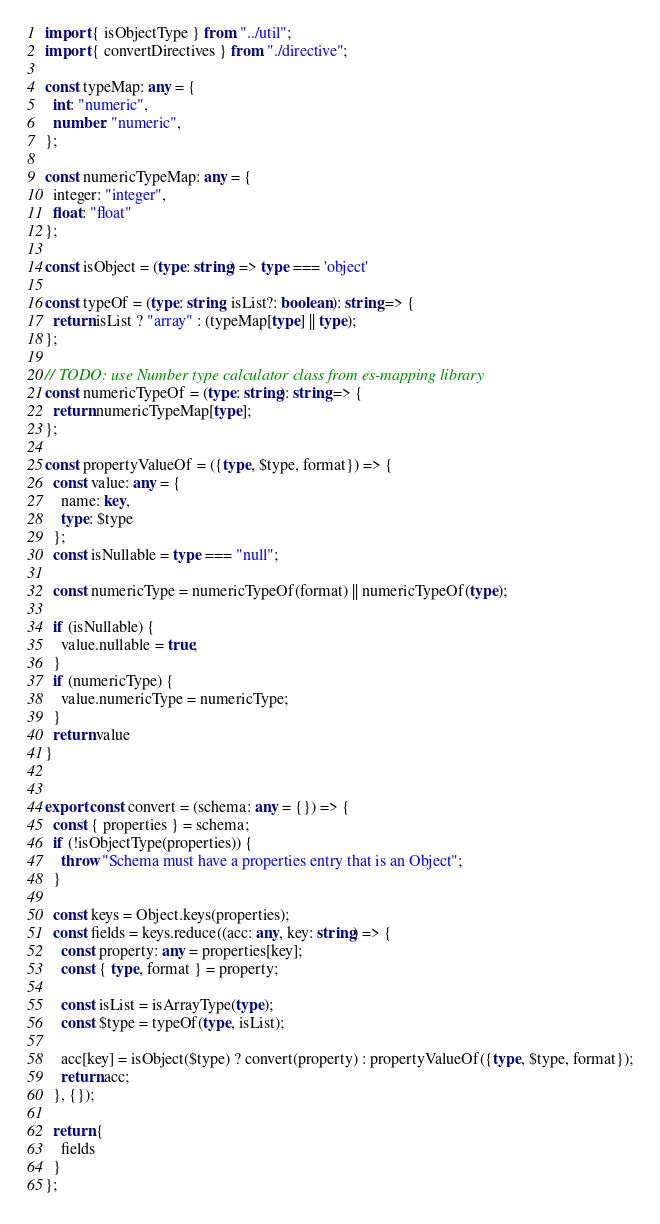<code> <loc_0><loc_0><loc_500><loc_500><_TypeScript_>import { isObjectType } from "../util";
import { convertDirectives } from "./directive";

const typeMap: any = {
  int: "numeric",
  number: "numeric",
};

const numericTypeMap: any = {
  integer: "integer",
  float: "float"
};

const isObject = (type: string) => type === 'object'

const typeOf = (type: string, isList?: boolean): string => {
  return isList ? "array" : (typeMap[type] || type);
};

// TODO: use Number type calculator class from es-mapping library
const numericTypeOf = (type: string): string => {
  return numericTypeMap[type];
};

const propertyValueOf = ({type, $type, format}) => {
  const value: any = {
    name: key,
    type: $type
  };
  const isNullable = type === "null";  

  const numericType = numericTypeOf(format) || numericTypeOf(type);

  if (isNullable) {
    value.nullable = true;
  }
  if (numericType) {
    value.numericType = numericType;
  }
  return value
}


export const convert = (schema: any = {}) => {
  const { properties } = schema;
  if (!isObjectType(properties)) {
    throw "Schema must have a properties entry that is an Object";
  }

  const keys = Object.keys(properties);
  const fields = keys.reduce((acc: any, key: string) => {
    const property: any = properties[key];
    const { type, format } = property;

    const isList = isArrayType(type);
    const $type = typeOf(type, isList);

    acc[key] = isObject($type) ? convert(property) : propertyValueOf({type, $type, format});
    return acc;
  }, {});

  return {
    fields
  }
};
</code> 